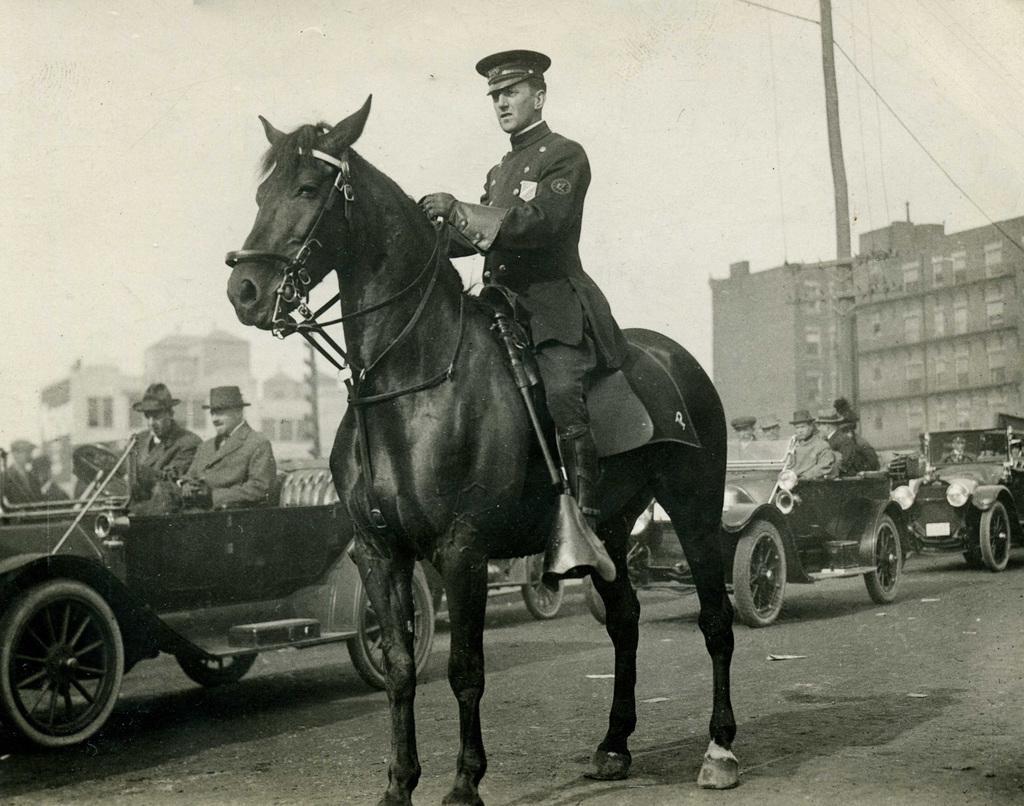How would you summarize this image in a sentence or two? In this picture there is a man who is sitting on the horse. There is a car in which two men are sitting. At the background there is a building and a pole. 